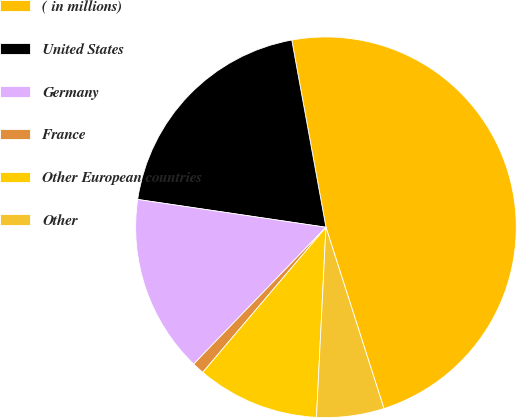Convert chart to OTSL. <chart><loc_0><loc_0><loc_500><loc_500><pie_chart><fcel>( in millions)<fcel>United States<fcel>Germany<fcel>France<fcel>Other European countries<fcel>Other<nl><fcel>47.94%<fcel>19.79%<fcel>15.1%<fcel>1.03%<fcel>10.41%<fcel>5.72%<nl></chart> 